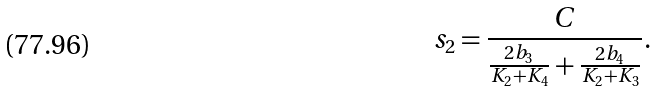Convert formula to latex. <formula><loc_0><loc_0><loc_500><loc_500>s _ { 2 } = \frac { C } { \frac { 2 b _ { 3 } } { K _ { 2 } + K _ { 4 } } + \frac { 2 b _ { 4 } } { K _ { 2 } + K _ { 3 } } } .</formula> 